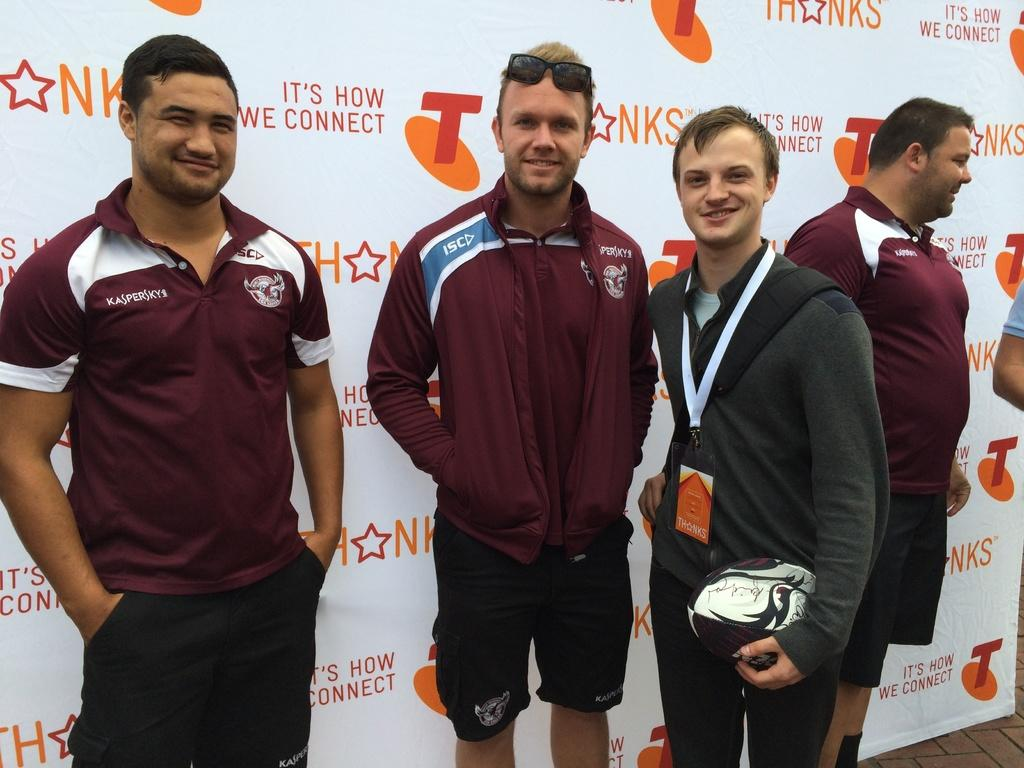<image>
Present a compact description of the photo's key features. Three men are facing the camera in front of a backdrop for NKS and T. 